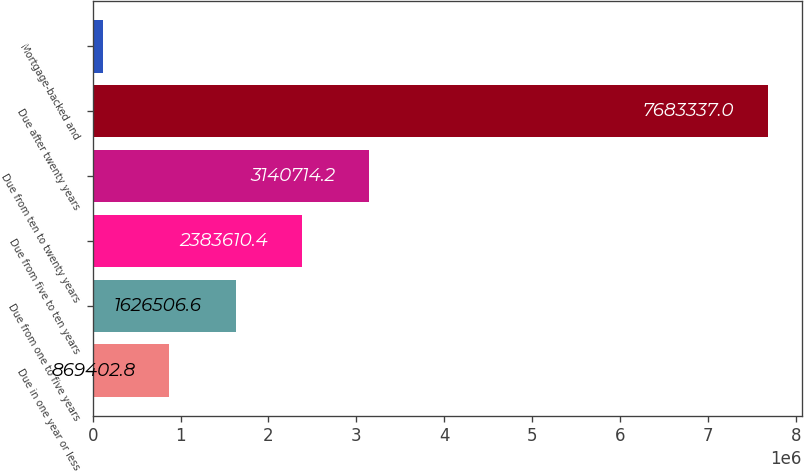<chart> <loc_0><loc_0><loc_500><loc_500><bar_chart><fcel>Due in one year or less<fcel>Due from one to five years<fcel>Due from five to ten years<fcel>Due from ten to twenty years<fcel>Due after twenty years<fcel>Mortgage-backed and<nl><fcel>869403<fcel>1.62651e+06<fcel>2.38361e+06<fcel>3.14071e+06<fcel>7.68334e+06<fcel>112299<nl></chart> 